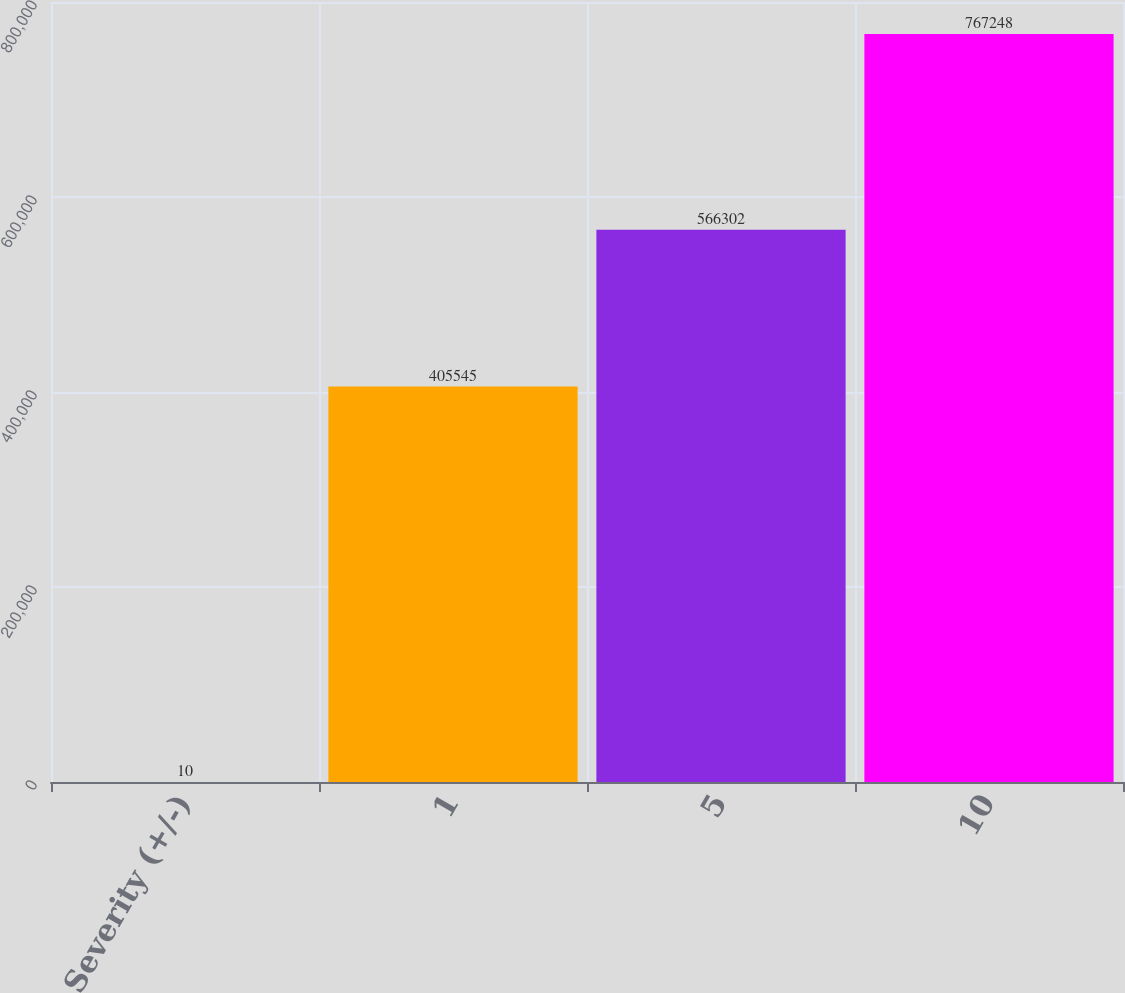<chart> <loc_0><loc_0><loc_500><loc_500><bar_chart><fcel>Severity (+/-)<fcel>1<fcel>5<fcel>10<nl><fcel>10<fcel>405545<fcel>566302<fcel>767248<nl></chart> 